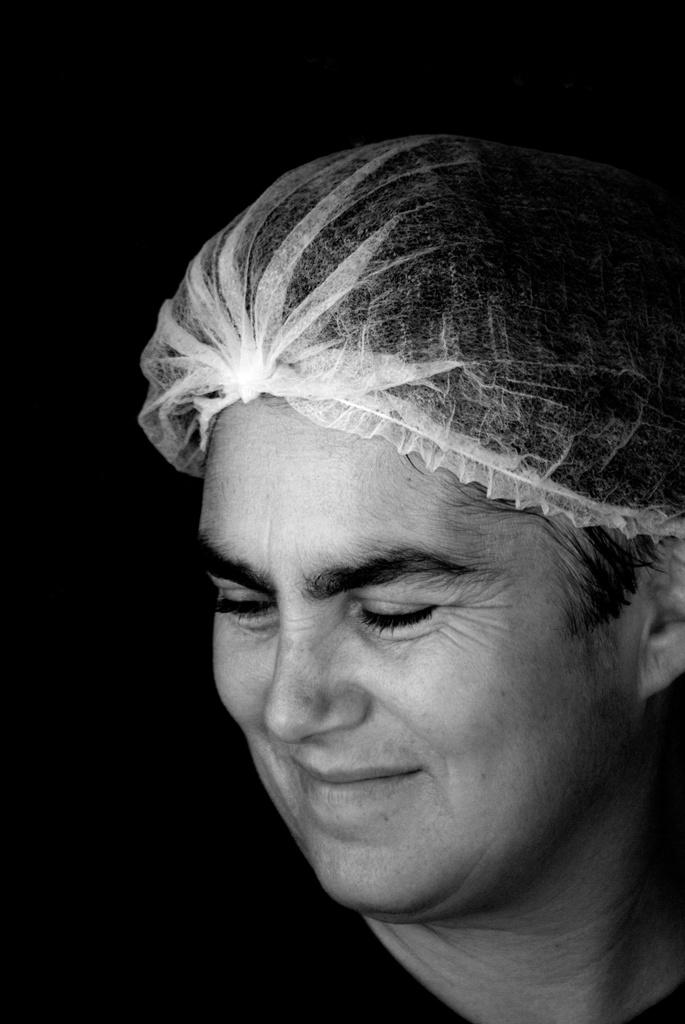What is the main subject of the picture? The main subject of the picture is a person's face. What expression does the person have in the picture? The person is smiling in the picture. What grade does the coach give to the person in the picture? There is no coach or grade present in the image; it only features a person's face with a smiling expression. 